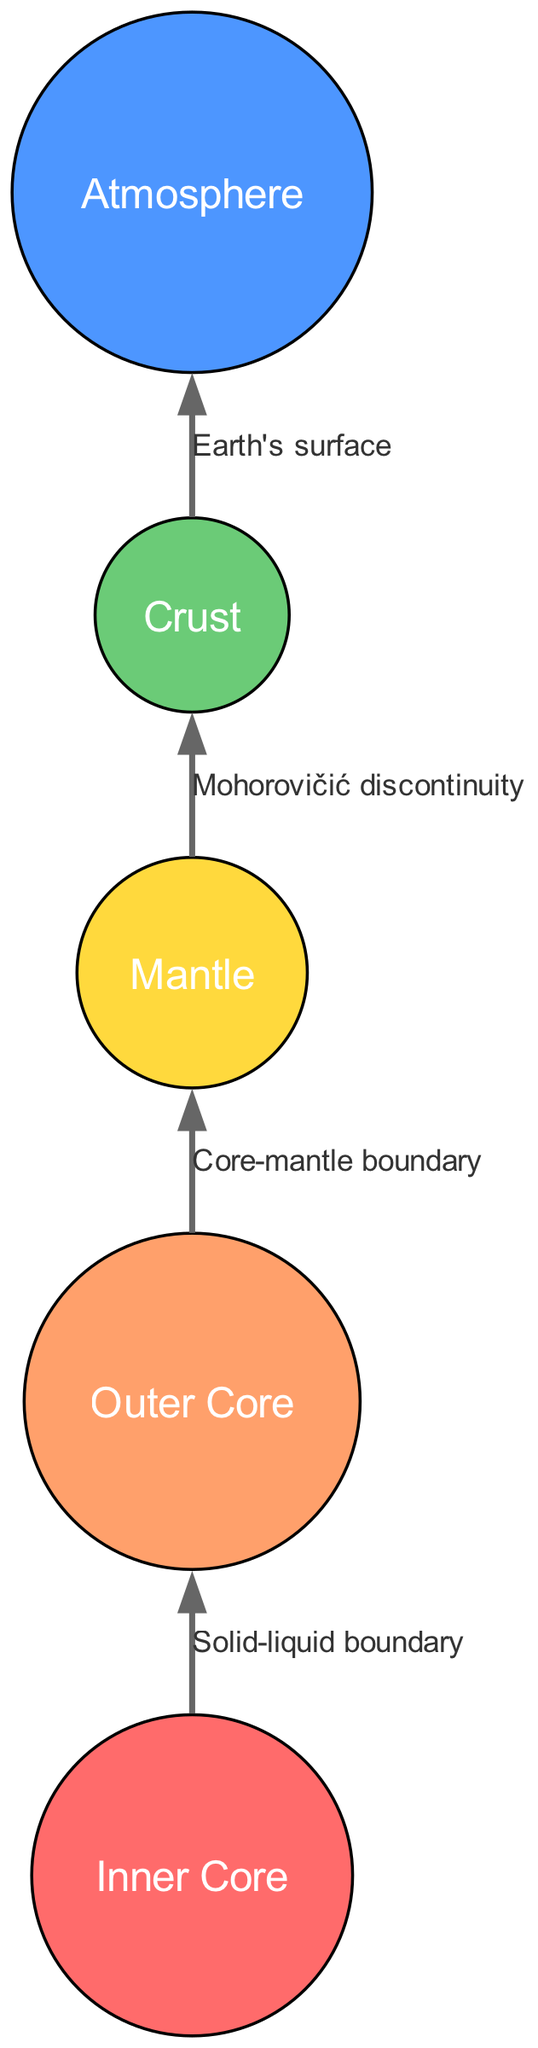What is the color of the Outer Core? The Outer Core's color is specifically defined in the data as "#FFA06B." This is a direct reference to the visual representation of that layer in the diagram.
Answer: #FFA06B How many layers are shown in the diagram? The diagram includes five distinct layers: Inner Core, Outer Core, Mantle, Crust, and Atmosphere. Counting each layer provides the total number of layers illustrated.
Answer: 5 What texture is associated with the Mantle? The data indicates the texture for the Mantle as "Lava lamp-inspired swirls." This specific detail directly correlates to the visual texture shown in the diagram.
Answer: Lava lamp-inspired swirls What boundary connects the Crust to the Atmosphere? According to the connections array, the edge labeled "Earth's surface" connects the Crust to the Atmosphere. This edge signifies the relationship between these two layers.
Answer: Earth's surface What is the connection type between the Inner Core and Outer Core? The diagram indicates a relationship labeled as "Solid-liquid boundary" between the Inner Core and Outer Core. This specifies the nature of the interaction between these two layers.
Answer: Solid-liquid boundary What color represents the Crust? The color for the Crust is represented in the data as "#6BCB77." This value is specified for visual identification in the diagram.
Answer: #6BCB77 How many connections are there in total? The connections array specifies four relationships that connect different layers. Counting each connection gives the total number of edges in the diagram.
Answer: 4 Which layer is directly above the Mantle? The data indicates that the layer directly above the Mantle is the Crust. This information is inferred from the connection labeled "Mohorovičić discontinuity."
Answer: Crust What texture is found in the Atmosphere? The texture associated with the Atmosphere is described as "Wispy cloud patterns," reflecting the artistic representation of that layer in the diagram.
Answer: Wispy cloud patterns 